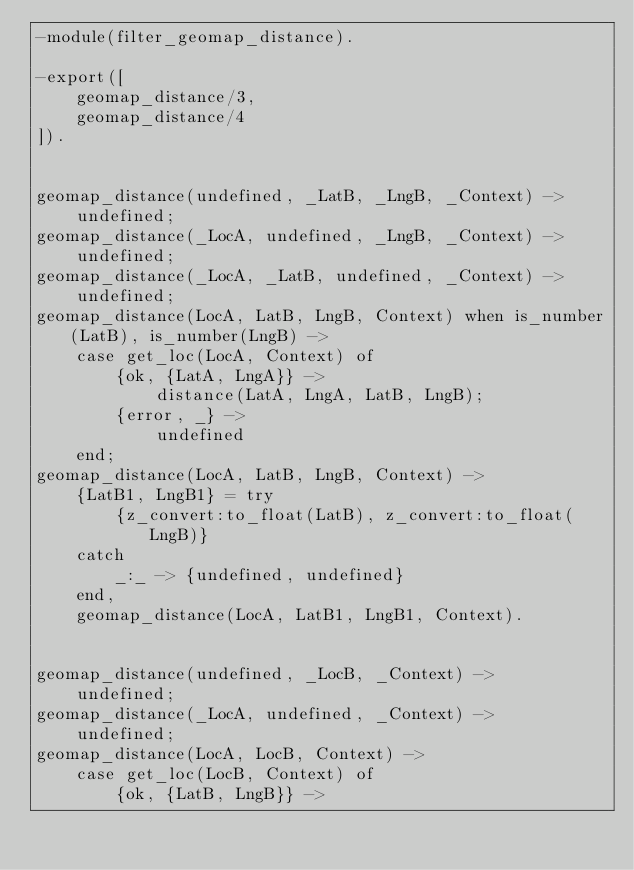<code> <loc_0><loc_0><loc_500><loc_500><_Erlang_>-module(filter_geomap_distance).

-export([
    geomap_distance/3,
    geomap_distance/4
]).


geomap_distance(undefined, _LatB, _LngB, _Context) ->
    undefined;
geomap_distance(_LocA, undefined, _LngB, _Context) ->
    undefined;
geomap_distance(_LocA, _LatB, undefined, _Context) ->
    undefined;
geomap_distance(LocA, LatB, LngB, Context) when is_number(LatB), is_number(LngB) ->
    case get_loc(LocA, Context) of
        {ok, {LatA, LngA}} ->
            distance(LatA, LngA, LatB, LngB);
        {error, _} ->
            undefined
    end;
geomap_distance(LocA, LatB, LngB, Context) ->
    {LatB1, LngB1} = try
        {z_convert:to_float(LatB), z_convert:to_float(LngB)}
    catch
        _:_ -> {undefined, undefined}
    end,
    geomap_distance(LocA, LatB1, LngB1, Context).


geomap_distance(undefined, _LocB, _Context) ->
    undefined;
geomap_distance(_LocA, undefined, _Context) ->
    undefined;
geomap_distance(LocA, LocB, Context) ->
    case get_loc(LocB, Context) of
        {ok, {LatB, LngB}} -></code> 